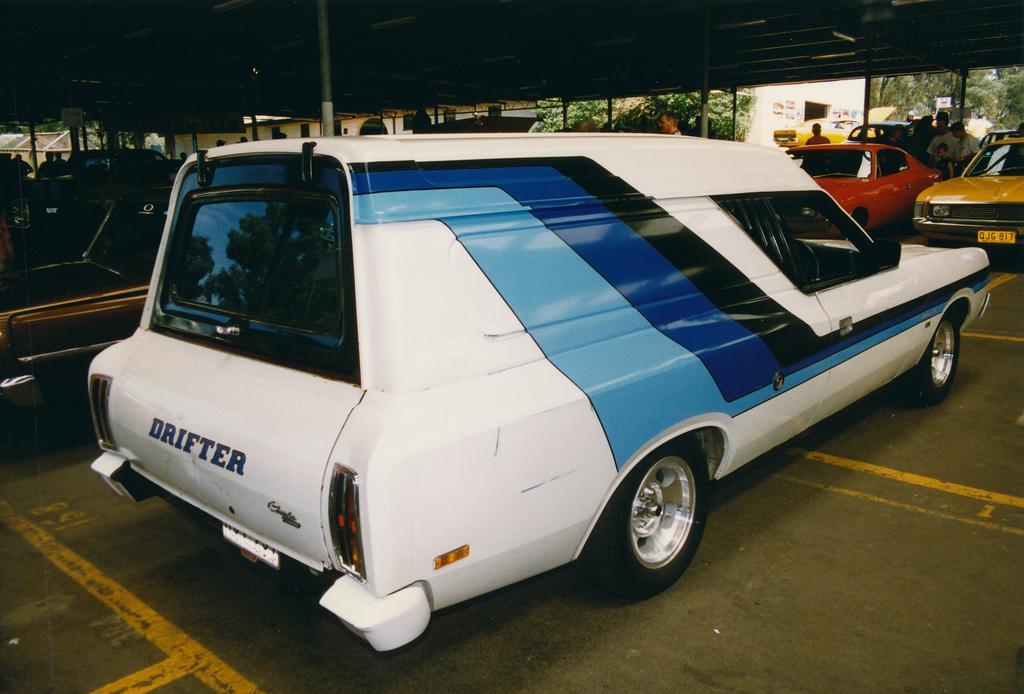Describe this image in one or two sentences. In this image it looks like a parking shed where there are so many cars parked one beside the other. In between them there are few people standing on the floor. In the background there is a building. Beside the building there are trees. In the middle there is a white color car on which there are blue stripes. 